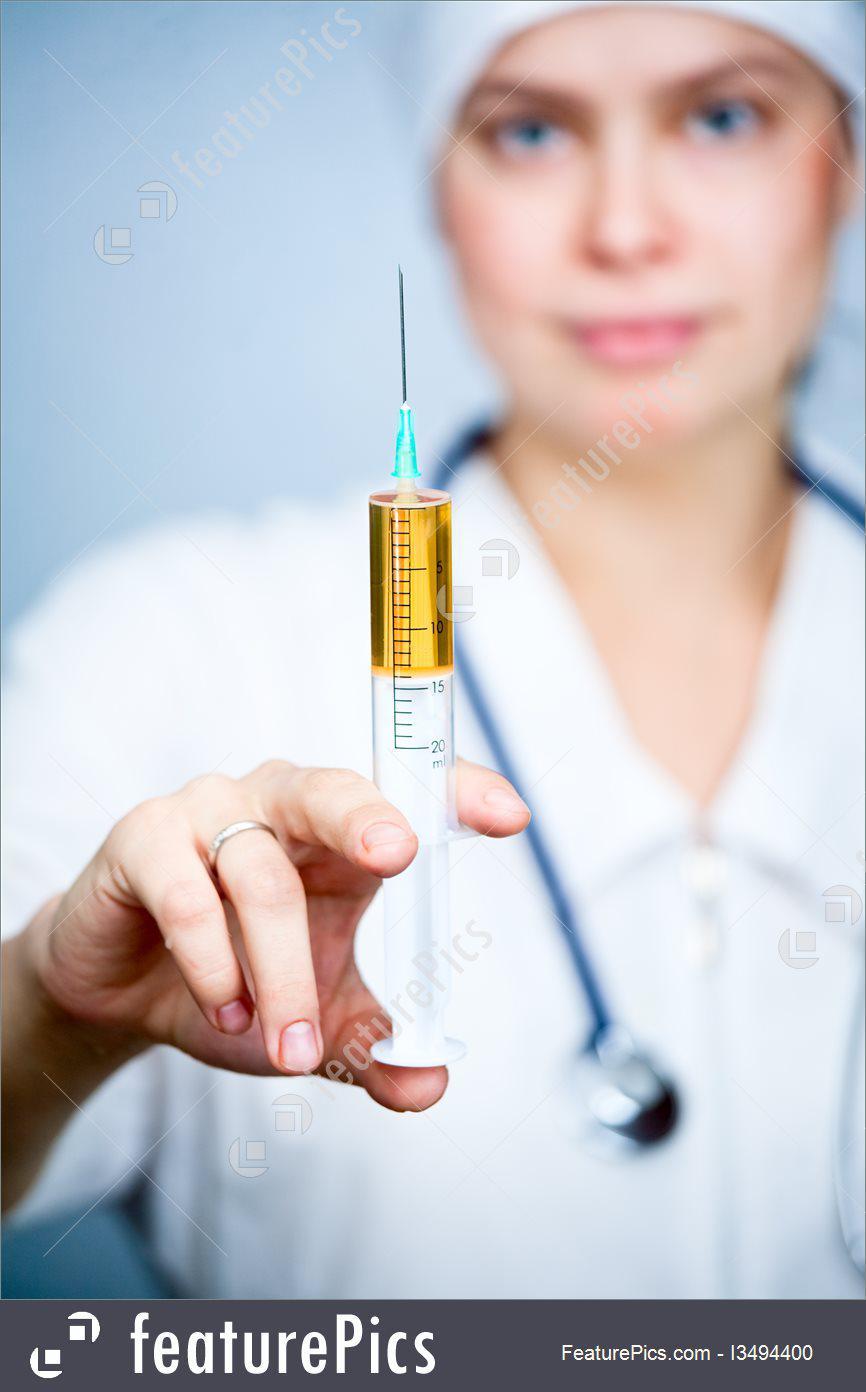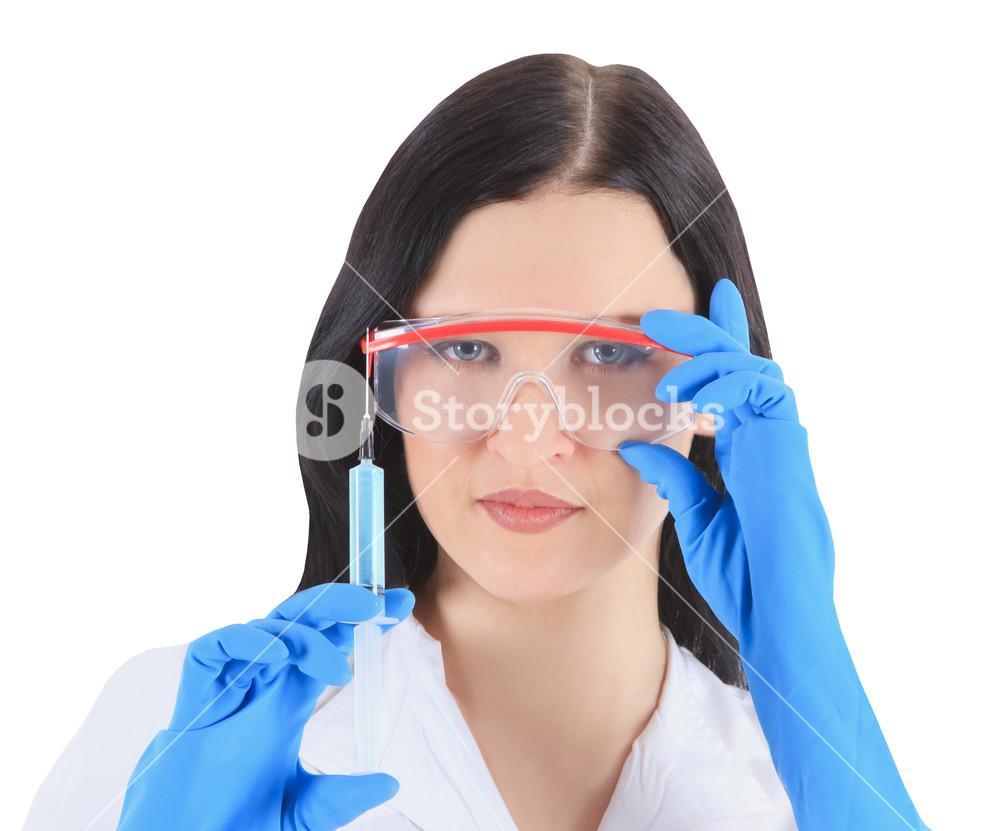The first image is the image on the left, the second image is the image on the right. Analyze the images presented: Is the assertion "There are two women holding a needle with colored liquid in it." valid? Answer yes or no. Yes. The first image is the image on the left, the second image is the image on the right. Given the left and right images, does the statement "The liquid in at least one of the syringes is orange." hold true? Answer yes or no. Yes. 